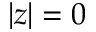Convert formula to latex. <formula><loc_0><loc_0><loc_500><loc_500>| z | = 0</formula> 